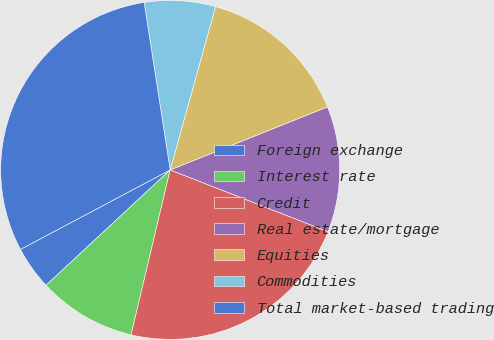Convert chart. <chart><loc_0><loc_0><loc_500><loc_500><pie_chart><fcel>Foreign exchange<fcel>Interest rate<fcel>Credit<fcel>Real estate/mortgage<fcel>Equities<fcel>Commodities<fcel>Total market-based trading<nl><fcel>4.15%<fcel>9.38%<fcel>22.77%<fcel>12.0%<fcel>14.62%<fcel>6.77%<fcel>30.32%<nl></chart> 